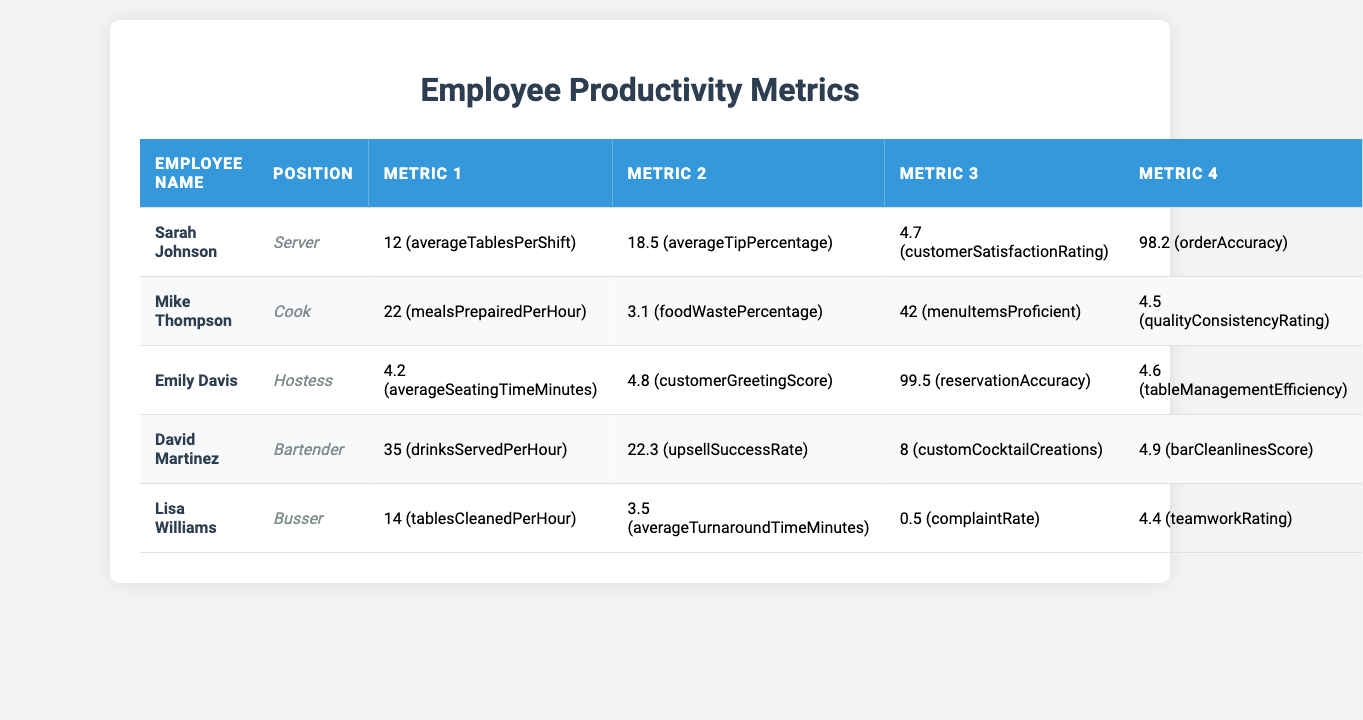What is the customer satisfaction rating for Sarah Johnson? The table lists Sarah Johnson's customer satisfaction rating as 4.7.
Answer: 4.7 How many meals does Mike Thompson prepare per hour? According to the table, Mike Thompson prepares 22 meals per hour.
Answer: 22 What is Emily Davis's reservation accuracy? From the data, it can be seen that Emily Davis has a reservation accuracy of 99.5%.
Answer: 99.5% What is the average tip percentage that Sarah Johnson receives? The table shows that Sarah Johnson has an average tip percentage of 18.5%.
Answer: 18.5% How many custom cocktail creations has David Martinez made? David Martinez has created 8 custom cocktails according to the table.
Answer: 8 Who has the highest customer greeting score, and what is the score? Emily Davis has the highest customer greeting score of 4.8 listed in the table.
Answer: Emily Davis, 4.8 What is the average turnaround time in minutes for Lisa Williams? Lisa Williams has an average turnaround time of 3.5 minutes as shown in the data.
Answer: 3.5 What is the food waste percentage for Mike Thompson? The table indicates Mike Thompson has a food waste percentage of 3.1%.
Answer: 3.1% Is David Martinez's bar cleanliness score higher than 4.5? Yes, David Martinez's bar cleanliness score is 4.9, which is higher than 4.5.
Answer: Yes If you combine Sarah Johnson's average tables per shift and Lisa Williams's tables cleaned per hour, what is the total? Sarah Johnson averages 12 tables per shift, and Lisa Williams cleans 14 tables per hour. Adding these gives 12 + 14 = 26.
Answer: 26 What is the difference in average tables per shift between Sarah Johnson and Lisa Williams? Sarah Johnson averages 12 tables per shift while Lisa Williams is a busser and is not directly compared in terms of shift tables. Thus, the answer pertains only to the role of Sarah Johnson, which remains at 12 since Lisa's metrics differ.
Answer: 12 Which employee has the highest upsell success rate and what is it? David Martinez has the highest upsell success rate listed at 22.3%.
Answer: David Martinez, 22.3% What is the overall quality consistency rating of the kitchen staff based on the metrics of Mike Thompson? Mike Thompson's quality consistency rating stands at 4.5 based on the data.
Answer: 4.5 How many tables does the bartender serve in an hour compared to the server? David Martinez serves 35 drinks per hour while Sarah Johnson manages 12 tables per shift, indicating a difference in their roles. The exact number of tables served by the bartender isn't specified; hence, interpret the conditions differently according to respective roles.
Answer: NA 